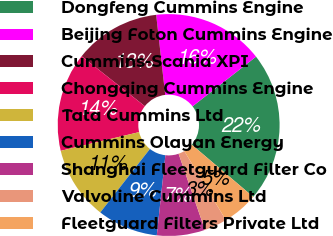Convert chart. <chart><loc_0><loc_0><loc_500><loc_500><pie_chart><fcel>Dongfeng Cummins Engine<fcel>Beijing Foton Cummins Engine<fcel>Cummins-Scania XPI<fcel>Chongqing Cummins Engine<fcel>Tata Cummins Ltd<fcel>Cummins Olayan Energy<fcel>Shanghai Fleetguard Filter Co<fcel>Valvoline Cummins Ltd<fcel>Fleetguard Filters Private Ltd<nl><fcel>21.77%<fcel>16.23%<fcel>12.55%<fcel>14.39%<fcel>10.7%<fcel>8.86%<fcel>7.01%<fcel>3.32%<fcel>5.17%<nl></chart> 